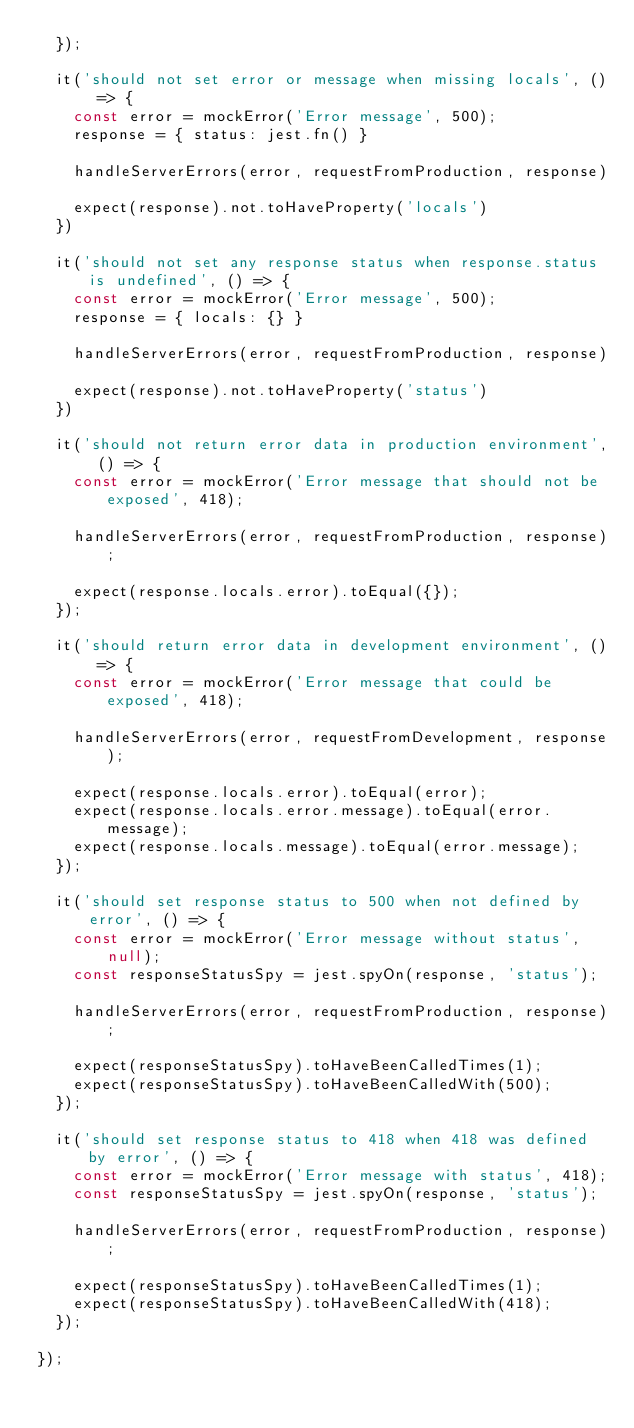<code> <loc_0><loc_0><loc_500><loc_500><_JavaScript_>  });

  it('should not set error or message when missing locals', () => {
    const error = mockError('Error message', 500);
    response = { status: jest.fn() }

    handleServerErrors(error, requestFromProduction, response)

    expect(response).not.toHaveProperty('locals')
  })

  it('should not set any response status when response.status is undefined', () => {
    const error = mockError('Error message', 500);
    response = { locals: {} }

    handleServerErrors(error, requestFromProduction, response)

    expect(response).not.toHaveProperty('status')
  })

  it('should not return error data in production environment', () => {
    const error = mockError('Error message that should not be exposed', 418);

    handleServerErrors(error, requestFromProduction, response);

    expect(response.locals.error).toEqual({});
  });

  it('should return error data in development environment', () => {
    const error = mockError('Error message that could be exposed', 418);

    handleServerErrors(error, requestFromDevelopment, response);

    expect(response.locals.error).toEqual(error);
    expect(response.locals.error.message).toEqual(error.message);
    expect(response.locals.message).toEqual(error.message);
  });

  it('should set response status to 500 when not defined by error', () => {
    const error = mockError('Error message without status', null);
    const responseStatusSpy = jest.spyOn(response, 'status');

    handleServerErrors(error, requestFromProduction, response);

    expect(responseStatusSpy).toHaveBeenCalledTimes(1);
    expect(responseStatusSpy).toHaveBeenCalledWith(500);
  });

  it('should set response status to 418 when 418 was defined by error', () => {
    const error = mockError('Error message with status', 418);
    const responseStatusSpy = jest.spyOn(response, 'status');

    handleServerErrors(error, requestFromProduction, response);

    expect(responseStatusSpy).toHaveBeenCalledTimes(1);
    expect(responseStatusSpy).toHaveBeenCalledWith(418);
  });

});
</code> 